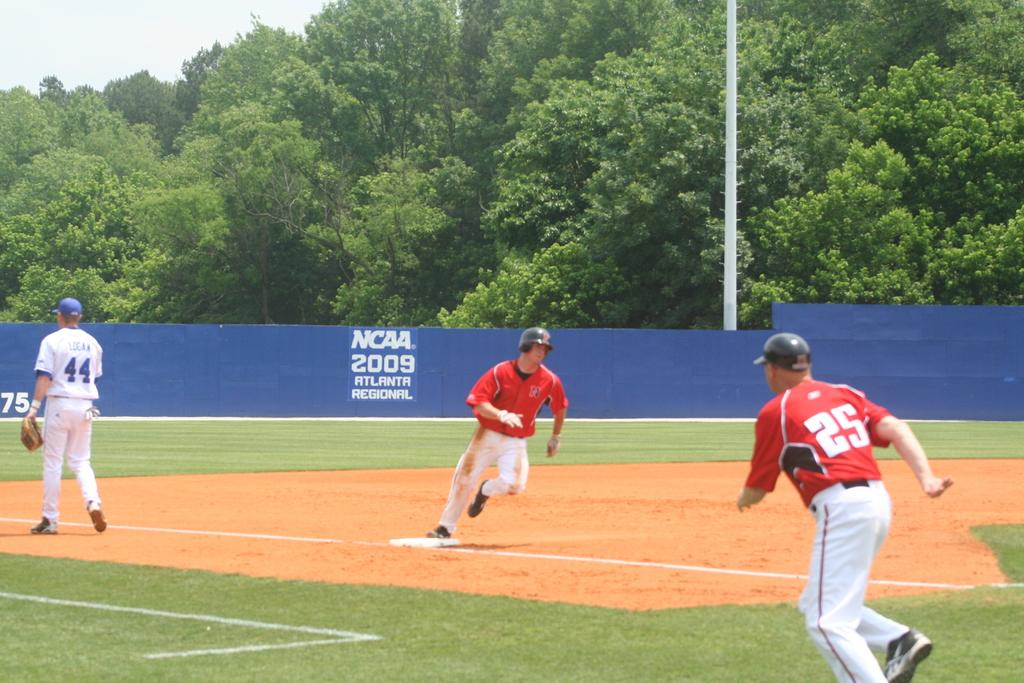<image>
Describe the image concisely. a few players on a field and one with the number 25 on them 